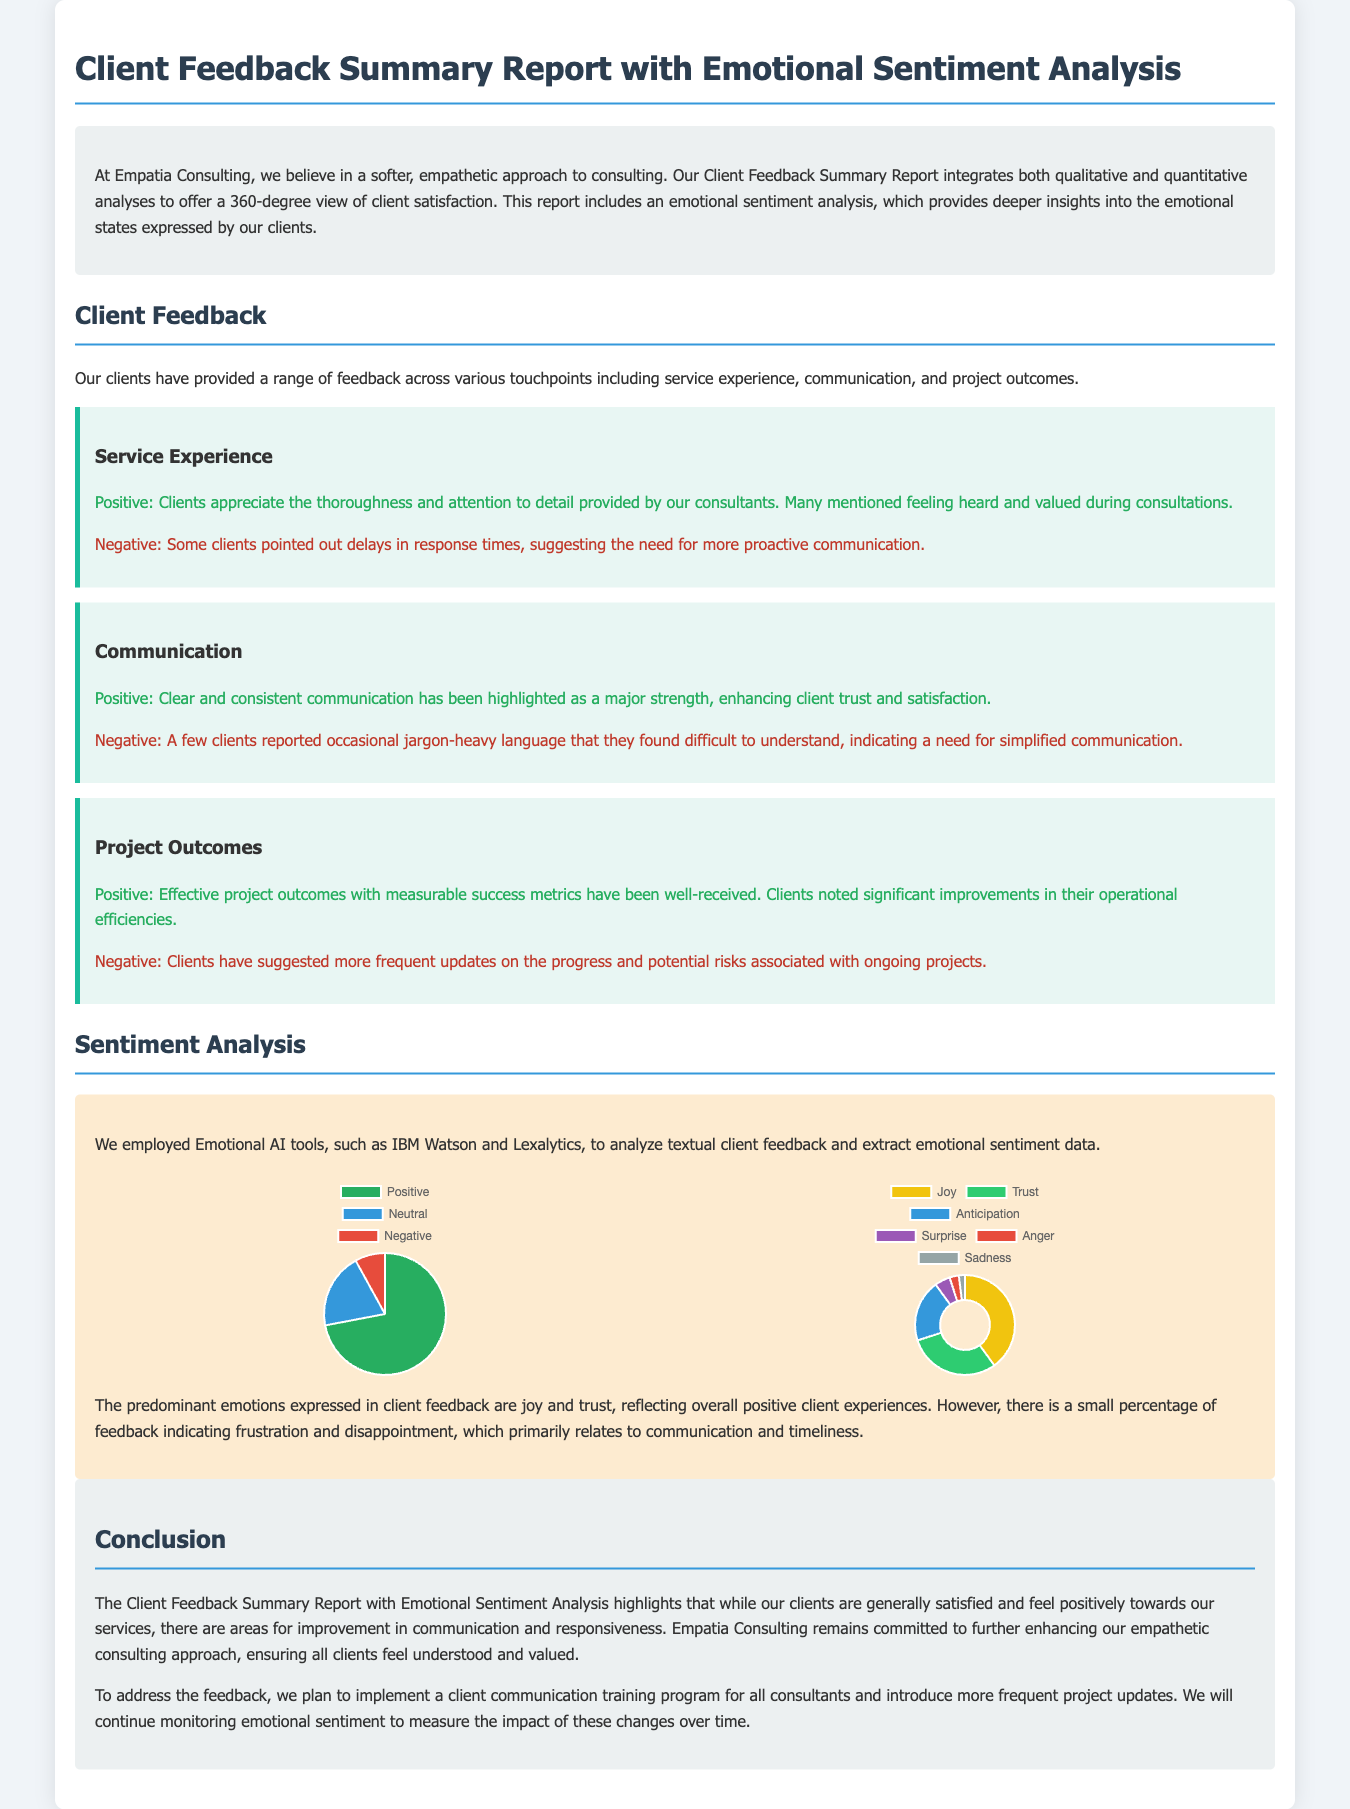What is the title of the report? The title of the report is mentioned prominently at the beginning of the document.
Answer: Client Feedback Summary Report with Emotional Sentiment Analysis What tools were used for sentiment analysis? The document lists the specific tools used for analysis within the sentiment analysis section.
Answer: IBM Watson and Lexalytics What percentage of client feedback is positive? The overall sentiment pie chart provides the precise data regarding positive feedback.
Answer: 72 Which emotion is expressed the most in client feedback? The emotions chart indicates the predominant emotion derived from the feedback.
Answer: Joy What specific area needs improvement according to client feedback? The conclusion discusses areas for improvement based on clients' suggestions.
Answer: Communication How many emotions are represented in the emotions chart? The emotions chart lists the different emotions analyzed from the feedback.
Answer: Six What is the main focus of the report? The introduction section explains the primary objective of the report.
Answer: Client satisfaction What percentage of feedback is classified as negative? The overall sentiment pie chart clearly shows the percentage breakdown of negative feedback.
Answer: 8 